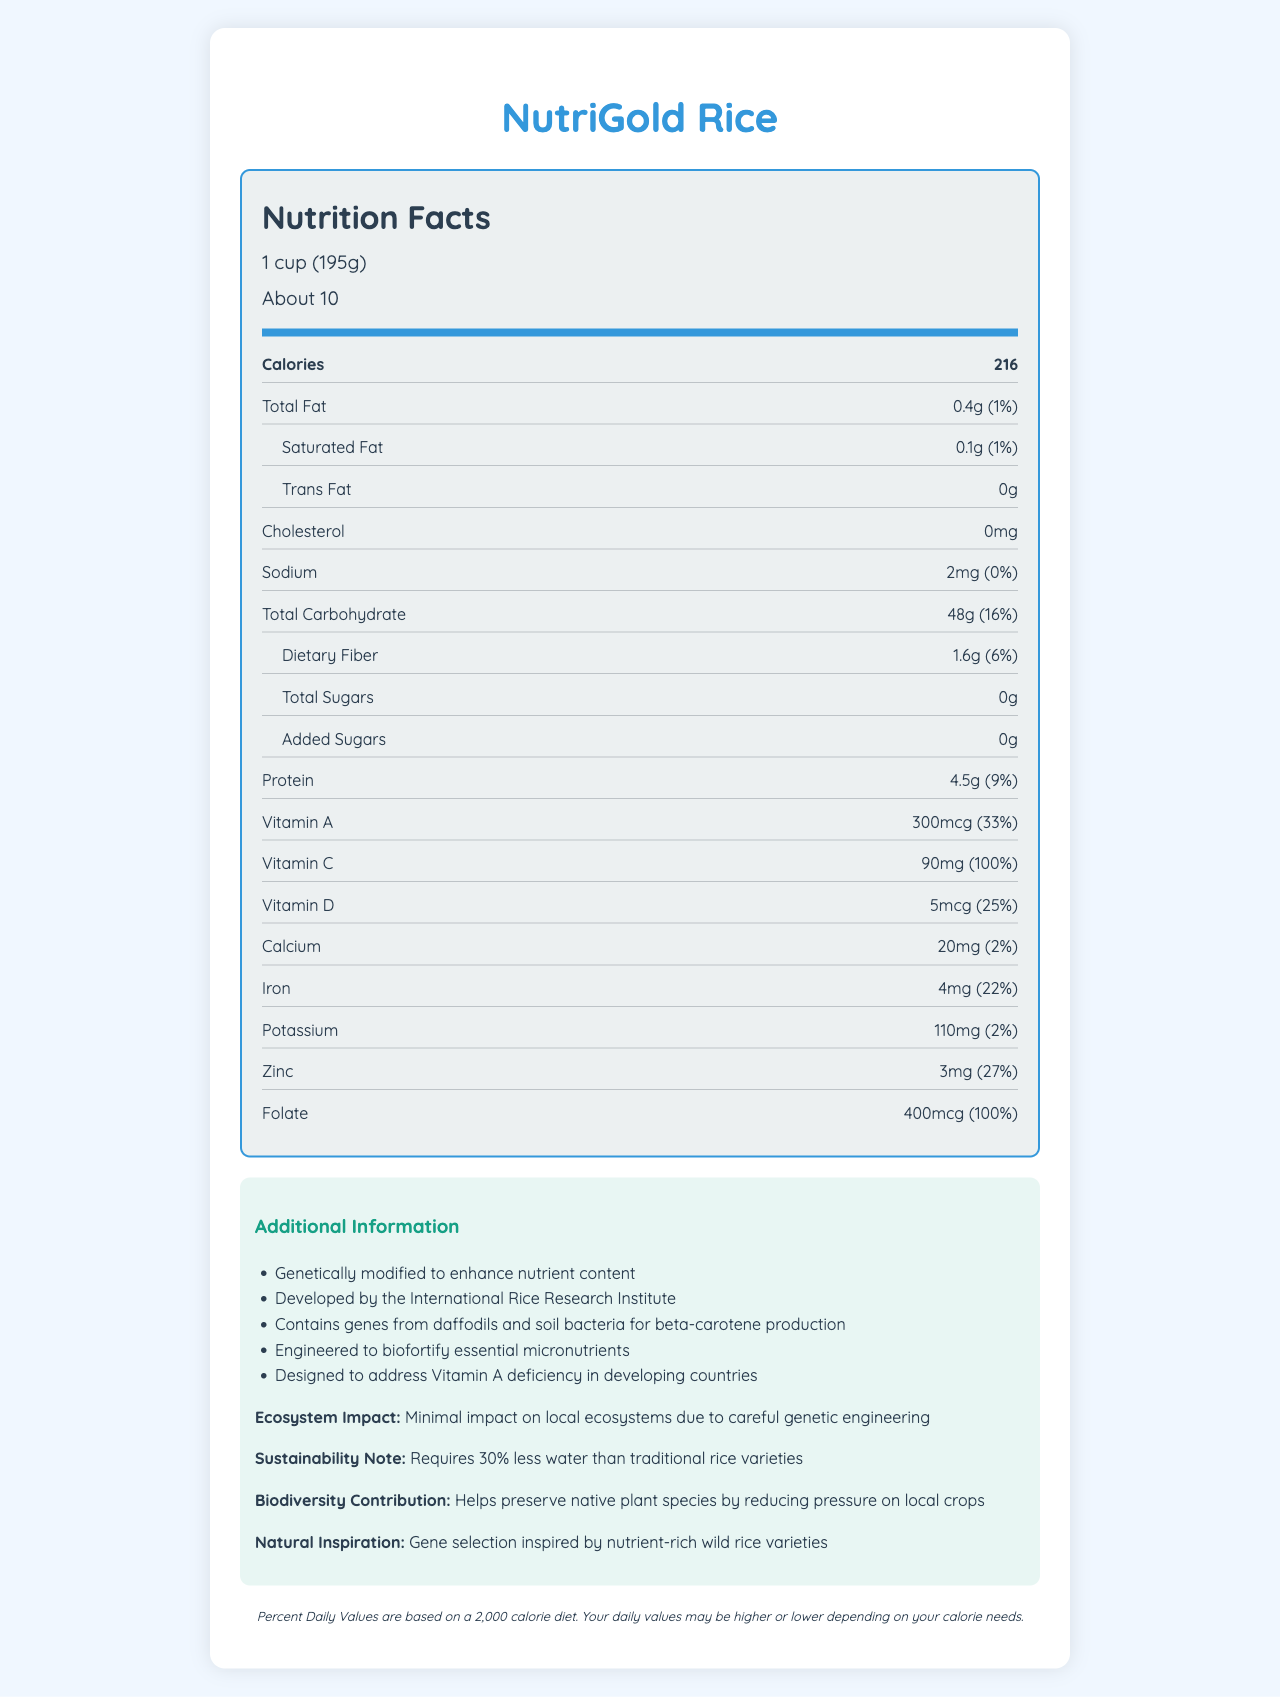what is the serving size? The serving size is explicitly listed as "1 cup (195g)" in the nutrition label.
Answer: 1 cup (195g) how many calories are in one serving? The document states that there are 216 calories per serving.
Answer: 216 what percentage of the daily value for Vitamin C does one serving provide? The nutrition label shows that one serving provides 100% of the daily value for Vitamin C.
Answer: 100% how much protein is in one serving? The label indicates that one serving contains 4.5 grams of protein.
Answer: 4.5g how much sodium is in one serving? The nutrition facts label lists sodium content as 2mg per serving.
Answer: 2mg which vitamin has the highest daily value percentage in one serving? A. Vitamin A B. Calcium C. Folate D. Vitamin D The document shows Folate as providing 100% of the daily value per serving, which is the highest.
Answer: C. Folate what types of genes were used to genetically modify NutriGold Rice? A. Genes from daffodils and soil bacteria B. Genes from corn and wheat C. Genes from fish and bacteria D. Genes from tomatoes and potatoes The additional information section states that the rice contains genes from daffodils and soil bacteria for beta-carotene production.
Answer: A. Genes from daffodils and soil bacteria does NutriGold Rice contain any trans fat? The nutrition label shows "0g" of trans fat.
Answer: No summarize the main purpose of NutriGold Rice designed by the International Rice Research Institute and its nutritional impact. The summary covers the main points from the document, highlighting its purpose, nutrient enhancements, ecological benefits, and its design for addressing specific nutritional deficiencies in developing countries.
Answer: NutriGold Rice is a genetically modified rice developed to combat malnutrition in developing countries. It has enhanced nutrient content, including high levels of Vitamin A, Vitamin C, and Folate. The rice is engineered to biofortify essential micronutrients, particularly to address Vitamin A deficiency. Additionally, it has a minimal environmental impact and requires less water to grow compared to traditional rice varieties. what is the percentage of the daily value of iron in one serving of NutriGold Rice? The document lists the iron content as providing 22% of the daily value per serving.
Answer: 22% how much dietary fiber does one serving contain? The nutrition label includes dietary fiber content as 1.6 grams per serving.
Answer: 1.6g what is the environmental impact of NutriGold Rice on local ecosystems? The additional information states that NutriGold Rice has minimal impact on local ecosystems due to careful genetic engineering.
Answer: Minimal impact how much water does NutriGold Rice require compared to traditional rice varieties? The sustainability note explains that NutriGold Rice requires 30% less water than traditional rice varieties.
Answer: 30% less water how many servings are there per container? The serving information on the document states there are about 10 servings per container.
Answer: About 10 what inspired the gene selection for NutriGold Rice? A. Wild rice varieties B. Traditional medicine C. Consumer demand D. Advanced technology The natural inspiration section mentions that the gene selection was inspired by nutrient-rich wild rice varieties.
Answer: A. Wild rice varieties what are the exact carbohydrate and protein contents per serving? According to the nutrition label, each serving contains 48 grams of total carbohydrates and 4.5 grams of protein.
Answer: 48g carbohydrates and 4.5g protein how many grams of added sugars are in one serving of NutriGold Rice? The label clearly mentions that there are 0 grams of added sugars.
Answer: 0g how does NutriGold Rice contribute to biodiversity? The biodiversity contribution section states that NutriGold Rice helps preserve native plant species by reducing the pressure on local crops.
Answer: It helps preserve native plant species by reducing pressure on local crops does the document state how NutriGold Rice specifically impacts human immune function? The document provides nutritional information and describes reducing deficiencies but does not mention specific impacts on human immune function.
Answer: Not enough information 